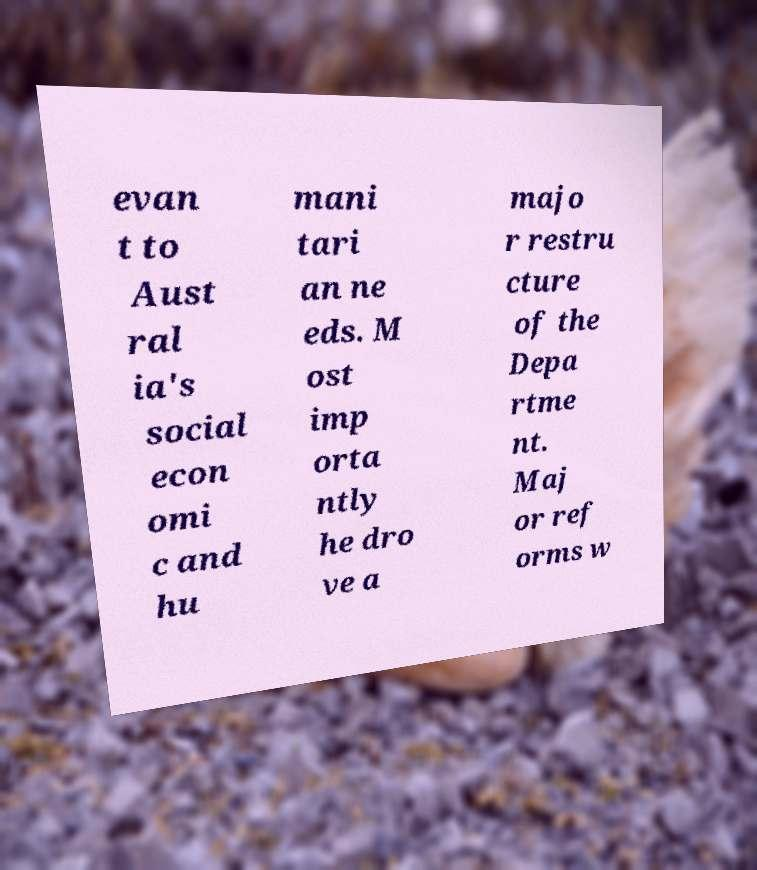Can you accurately transcribe the text from the provided image for me? evan t to Aust ral ia's social econ omi c and hu mani tari an ne eds. M ost imp orta ntly he dro ve a majo r restru cture of the Depa rtme nt. Maj or ref orms w 